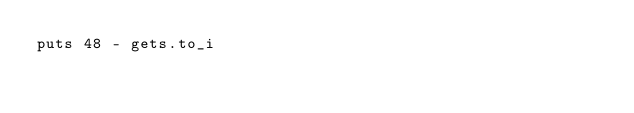<code> <loc_0><loc_0><loc_500><loc_500><_Ruby_>puts 48 - gets.to_i</code> 